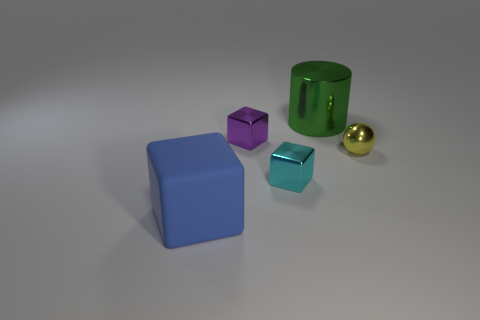Subtract all tiny cubes. How many cubes are left? 1 Add 5 big cyan rubber cylinders. How many objects exist? 10 Add 5 purple metallic things. How many purple metallic things are left? 6 Add 3 tiny purple things. How many tiny purple things exist? 4 Subtract all cyan cubes. How many cubes are left? 2 Subtract 1 green cylinders. How many objects are left? 4 Subtract all balls. How many objects are left? 4 Subtract 1 cylinders. How many cylinders are left? 0 Subtract all cyan spheres. Subtract all blue cubes. How many spheres are left? 1 Subtract all brown cylinders. How many purple blocks are left? 1 